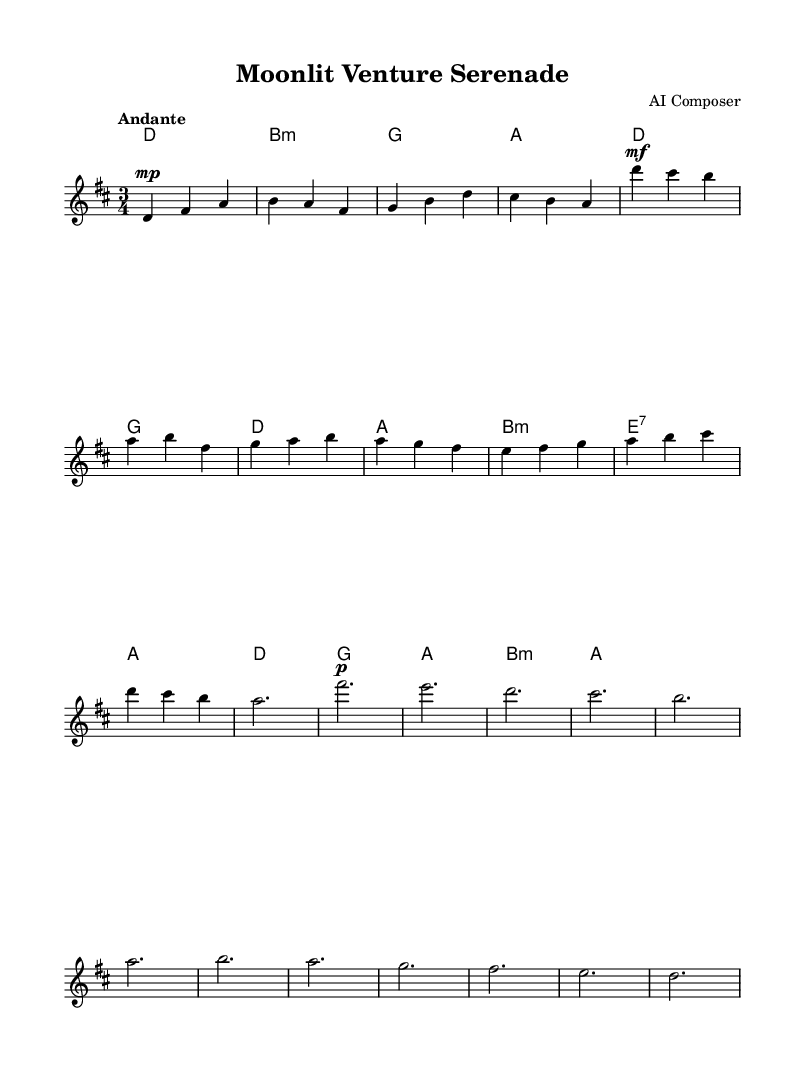What is the key signature of this music? The key signature indicates the sharps or flats in the piece; in this case, there is an F sharp and a C sharp, which means the key is D major.
Answer: D major What is the time signature of the piece? The time signature, located at the beginning of the score, shows that there are three beats per measure, indicating it is in 3/4 time.
Answer: 3/4 What is the tempo marking indicated for the piece? The tempo marking "Andante" suggests a moderate pace. It provides an idea of how fast the piece should be played.
Answer: Andante How many measures are in the verse section? Counting the measures labeled in the verse section, there are eight distinct measures that form that part of the piece.
Answer: Eight What is the dynamic marking for the introduction? The introduction starts with a dynamic marking of "mp," which stands for mezzo-piano, indicating a moderately soft volume.
Answer: Mezzo-piano Which chord is used at the beginning of the introduction? The first chord in the introduction is a D major chord, as indicated in the harmonies section.
Answer: D major What emotional characteristic does this music embody based on its structure? The piece, with its flowing melody and gentle dynamics in a 3/4 time signature, embodies a romantic and intimate quality ideal for serene settings.
Answer: Romantic 